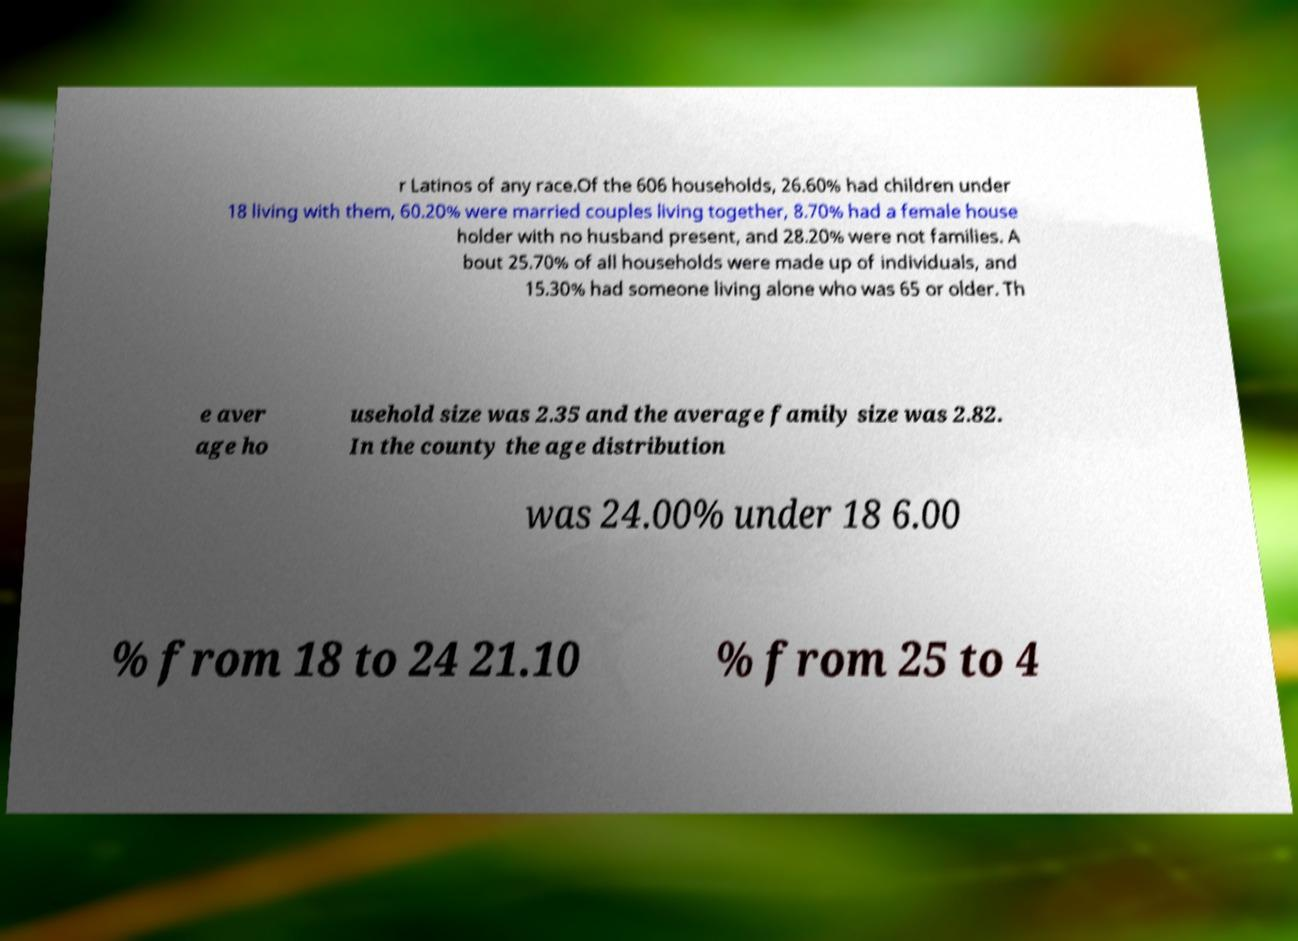Can you read and provide the text displayed in the image?This photo seems to have some interesting text. Can you extract and type it out for me? r Latinos of any race.Of the 606 households, 26.60% had children under 18 living with them, 60.20% were married couples living together, 8.70% had a female house holder with no husband present, and 28.20% were not families. A bout 25.70% of all households were made up of individuals, and 15.30% had someone living alone who was 65 or older. Th e aver age ho usehold size was 2.35 and the average family size was 2.82. In the county the age distribution was 24.00% under 18 6.00 % from 18 to 24 21.10 % from 25 to 4 